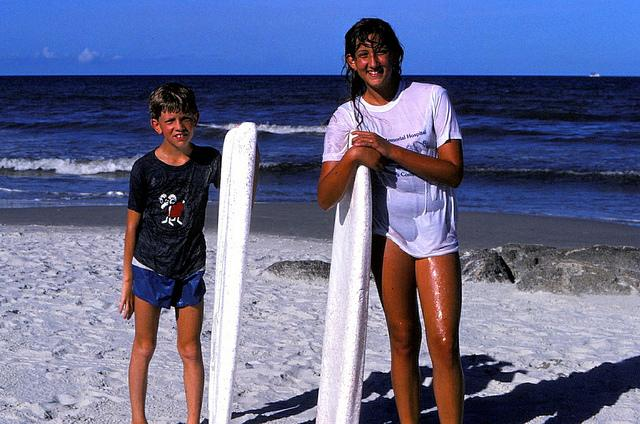How do these people know each other? Please explain your reasoning. siblings. These kids are siblings. 